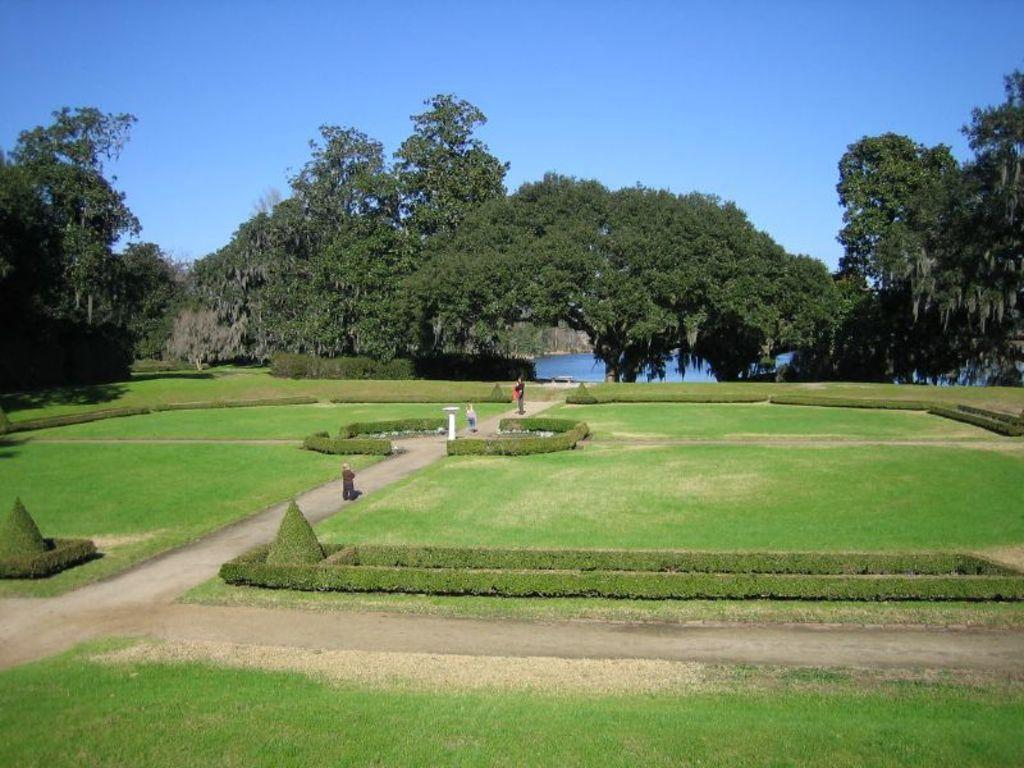What type of vegetation can be seen in the image? There is grass in the image. What are the people doing in the image? People are present on a walkway. What can be seen in the background of the image? There are trees at the back of the image. What is visible behind the trees in the image? There is water visible behind the trees. What type of ink is being used by the church in the image? There is no church present in the image, so there is no ink being used. What type of flesh can be seen on the people in the image? The question is inappropriate and not relevant to the image, as it focuses on a personal and sensitive aspect of the people. 